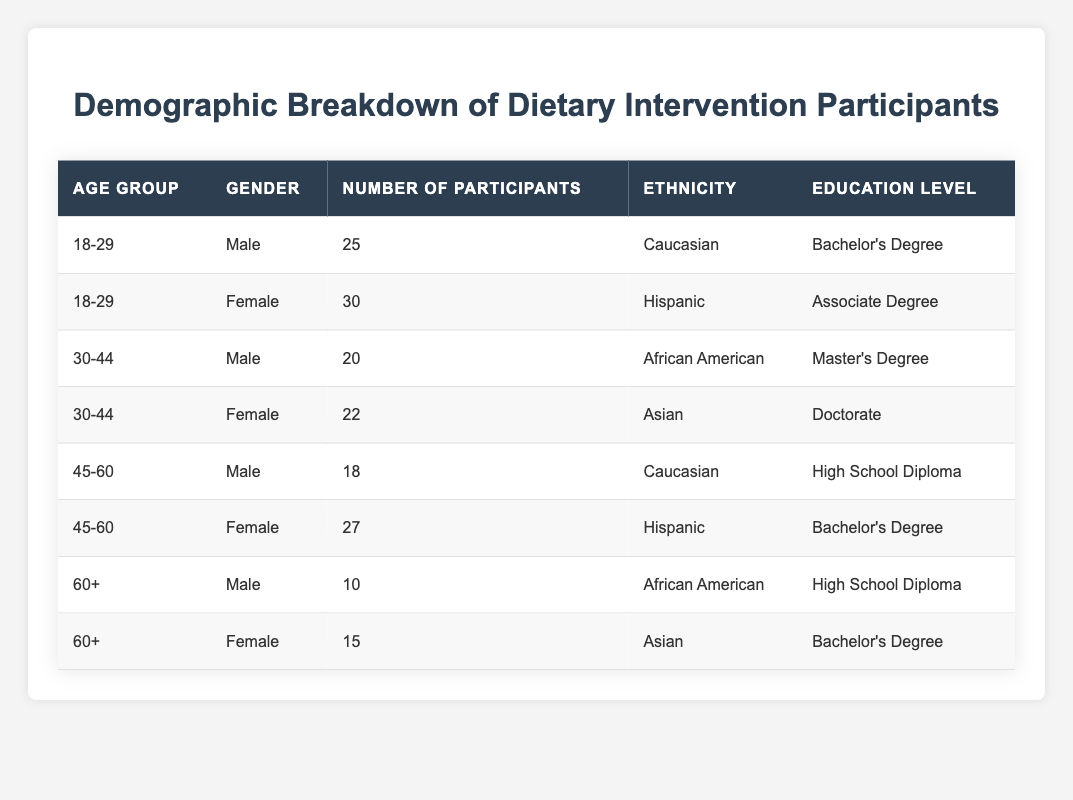What is the total number of male participants? The table lists male participants in different age groups. Adding their numbers: 25 (18-29) + 20 (30-44) + 18 (45-60) + 10 (60+) = 73.
Answer: 73 What is the percentage of female participants among the total participants? The total number of participants is 25 (male, 18-29) + 30 (female, 18-29) + 20 (male, 30-44) + 22 (female, 30-44) + 18 (male, 45-60) + 27 (female, 45-60) + 10 (male, 60+) + 15 (female, 60+) =  25 + 30 + 20 + 22 + 18 + 27 + 10 + 15 =  167. The number of female participants is 30 + 22 + 27 + 15 = 94. Therefore, the percentage is (94/167) * 100 = 56.3%.
Answer: 56.3% Is there any participant in the age group 60+ who has a Master's Degree? The table shows no entries for the age group 60+ with a Master's Degree listed. Hence, the answer is no.
Answer: No What age group had the highest number of participants, and how many were there? The total number of participants in each age group is: 18-29: 55, 30-44: 42, 45-60: 45, and 60+: 25. The age group 18-29 has the highest total of 55 participants.
Answer: 18-29, 55 How many participants have a High School Diploma among all age groups? Review the table for participants with a High School Diploma: 18 (45-60, Male) + 10 (60+, Male) = 28 participants.
Answer: 28 What is the total number of participants who identify as Hispanic? The table shows Hispanic participants in two categories: 30 (female, 18-29) + 27 (female, 45-60) = 57 total participants identify as Hispanic.
Answer: 57 Which gender in the 45-60 age group has more participants? The 45-60 age group has 18 males and 27 females. Since 27 is greater than 18, females have more participants in this group.
Answer: Female What is the average number of participants per education level? The education levels, along with their numbers of participants, are: Bachelor's Degree (55), Associate Degree (30), Master's Degree (20), Doctorate (22), and High School Diploma (28). The sums yield a total of 155 participants across five education levels, giving an average of 155/5 = 31.
Answer: 31 How many more female participants are there compared to male participants in the 30-44 age group? In the 30-44 age group, there are 20 males and 22 females. The difference is 22 (female) - 20 (male) = 2 more females than males.
Answer: 2 What percentage of participants in the 18-29 age group is male? The participants in the 18-29 age group are 25 males and 30 females, totaling 55. The percentage of male participants is (25/55) * 100 = 45.5%.
Answer: 45.5% 